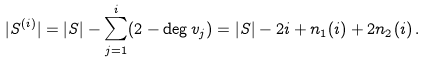Convert formula to latex. <formula><loc_0><loc_0><loc_500><loc_500>| S ^ { ( i ) } | = | S | - \sum _ { j = 1 } ^ { i } ( 2 - \deg v _ { j } ) = | S | - 2 i + n _ { 1 } ( i ) + 2 n _ { 2 } ( i ) \, .</formula> 